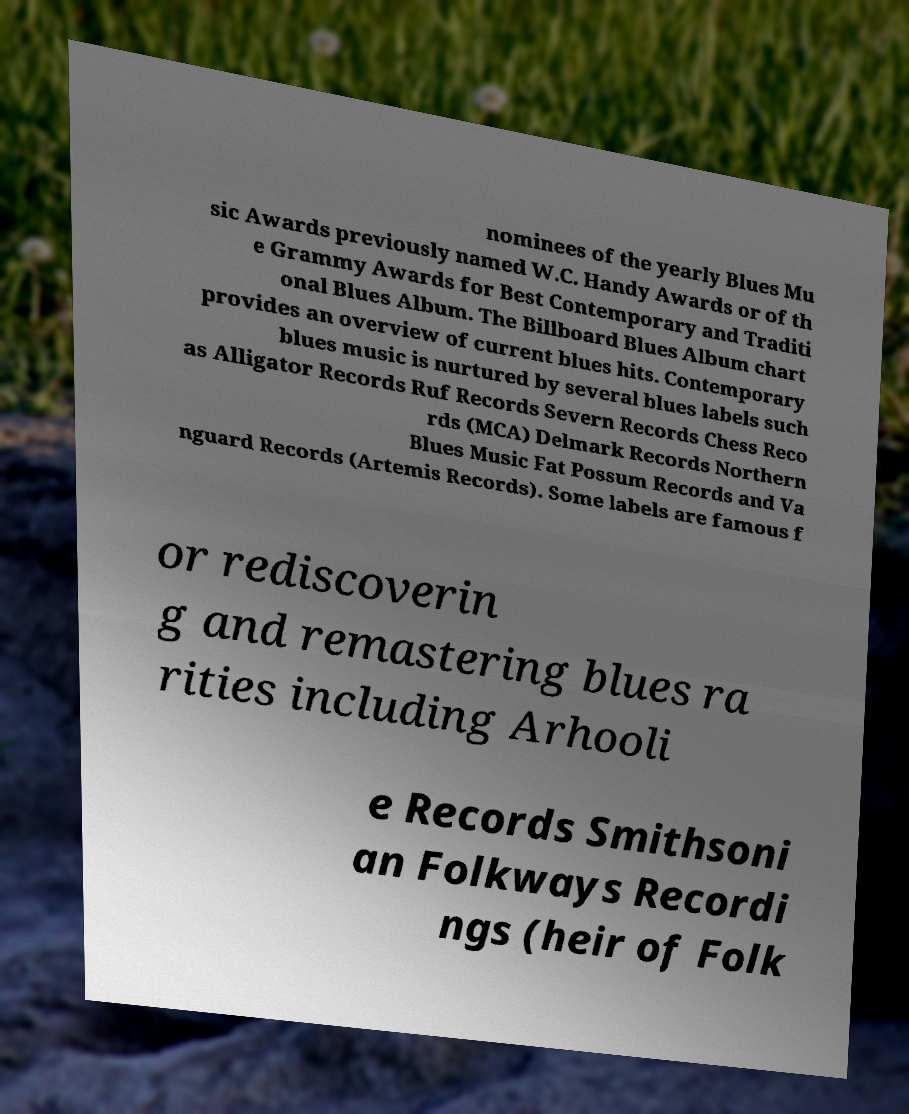Please read and relay the text visible in this image. What does it say? nominees of the yearly Blues Mu sic Awards previously named W.C. Handy Awards or of th e Grammy Awards for Best Contemporary and Traditi onal Blues Album. The Billboard Blues Album chart provides an overview of current blues hits. Contemporary blues music is nurtured by several blues labels such as Alligator Records Ruf Records Severn Records Chess Reco rds (MCA) Delmark Records Northern Blues Music Fat Possum Records and Va nguard Records (Artemis Records). Some labels are famous f or rediscoverin g and remastering blues ra rities including Arhooli e Records Smithsoni an Folkways Recordi ngs (heir of Folk 